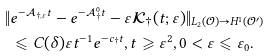<formula> <loc_0><loc_0><loc_500><loc_500>\| & e ^ { - \mathcal { A } _ { \dag , \varepsilon } t } - e ^ { - \mathcal { A } _ { \dag } ^ { 0 } t } - \varepsilon \mathcal { K } _ { \dag } ( t ; \varepsilon ) \| _ { L _ { 2 } ( \mathcal { O } ) \rightarrow H ^ { 1 } ( \mathcal { O } ^ { \prime } ) } \\ & \leqslant { C } ( \delta ) \varepsilon t ^ { - 1 } e ^ { - c _ { \dag } t } , t \geqslant \varepsilon ^ { 2 } , 0 < \varepsilon \leqslant \varepsilon _ { 0 } .</formula> 